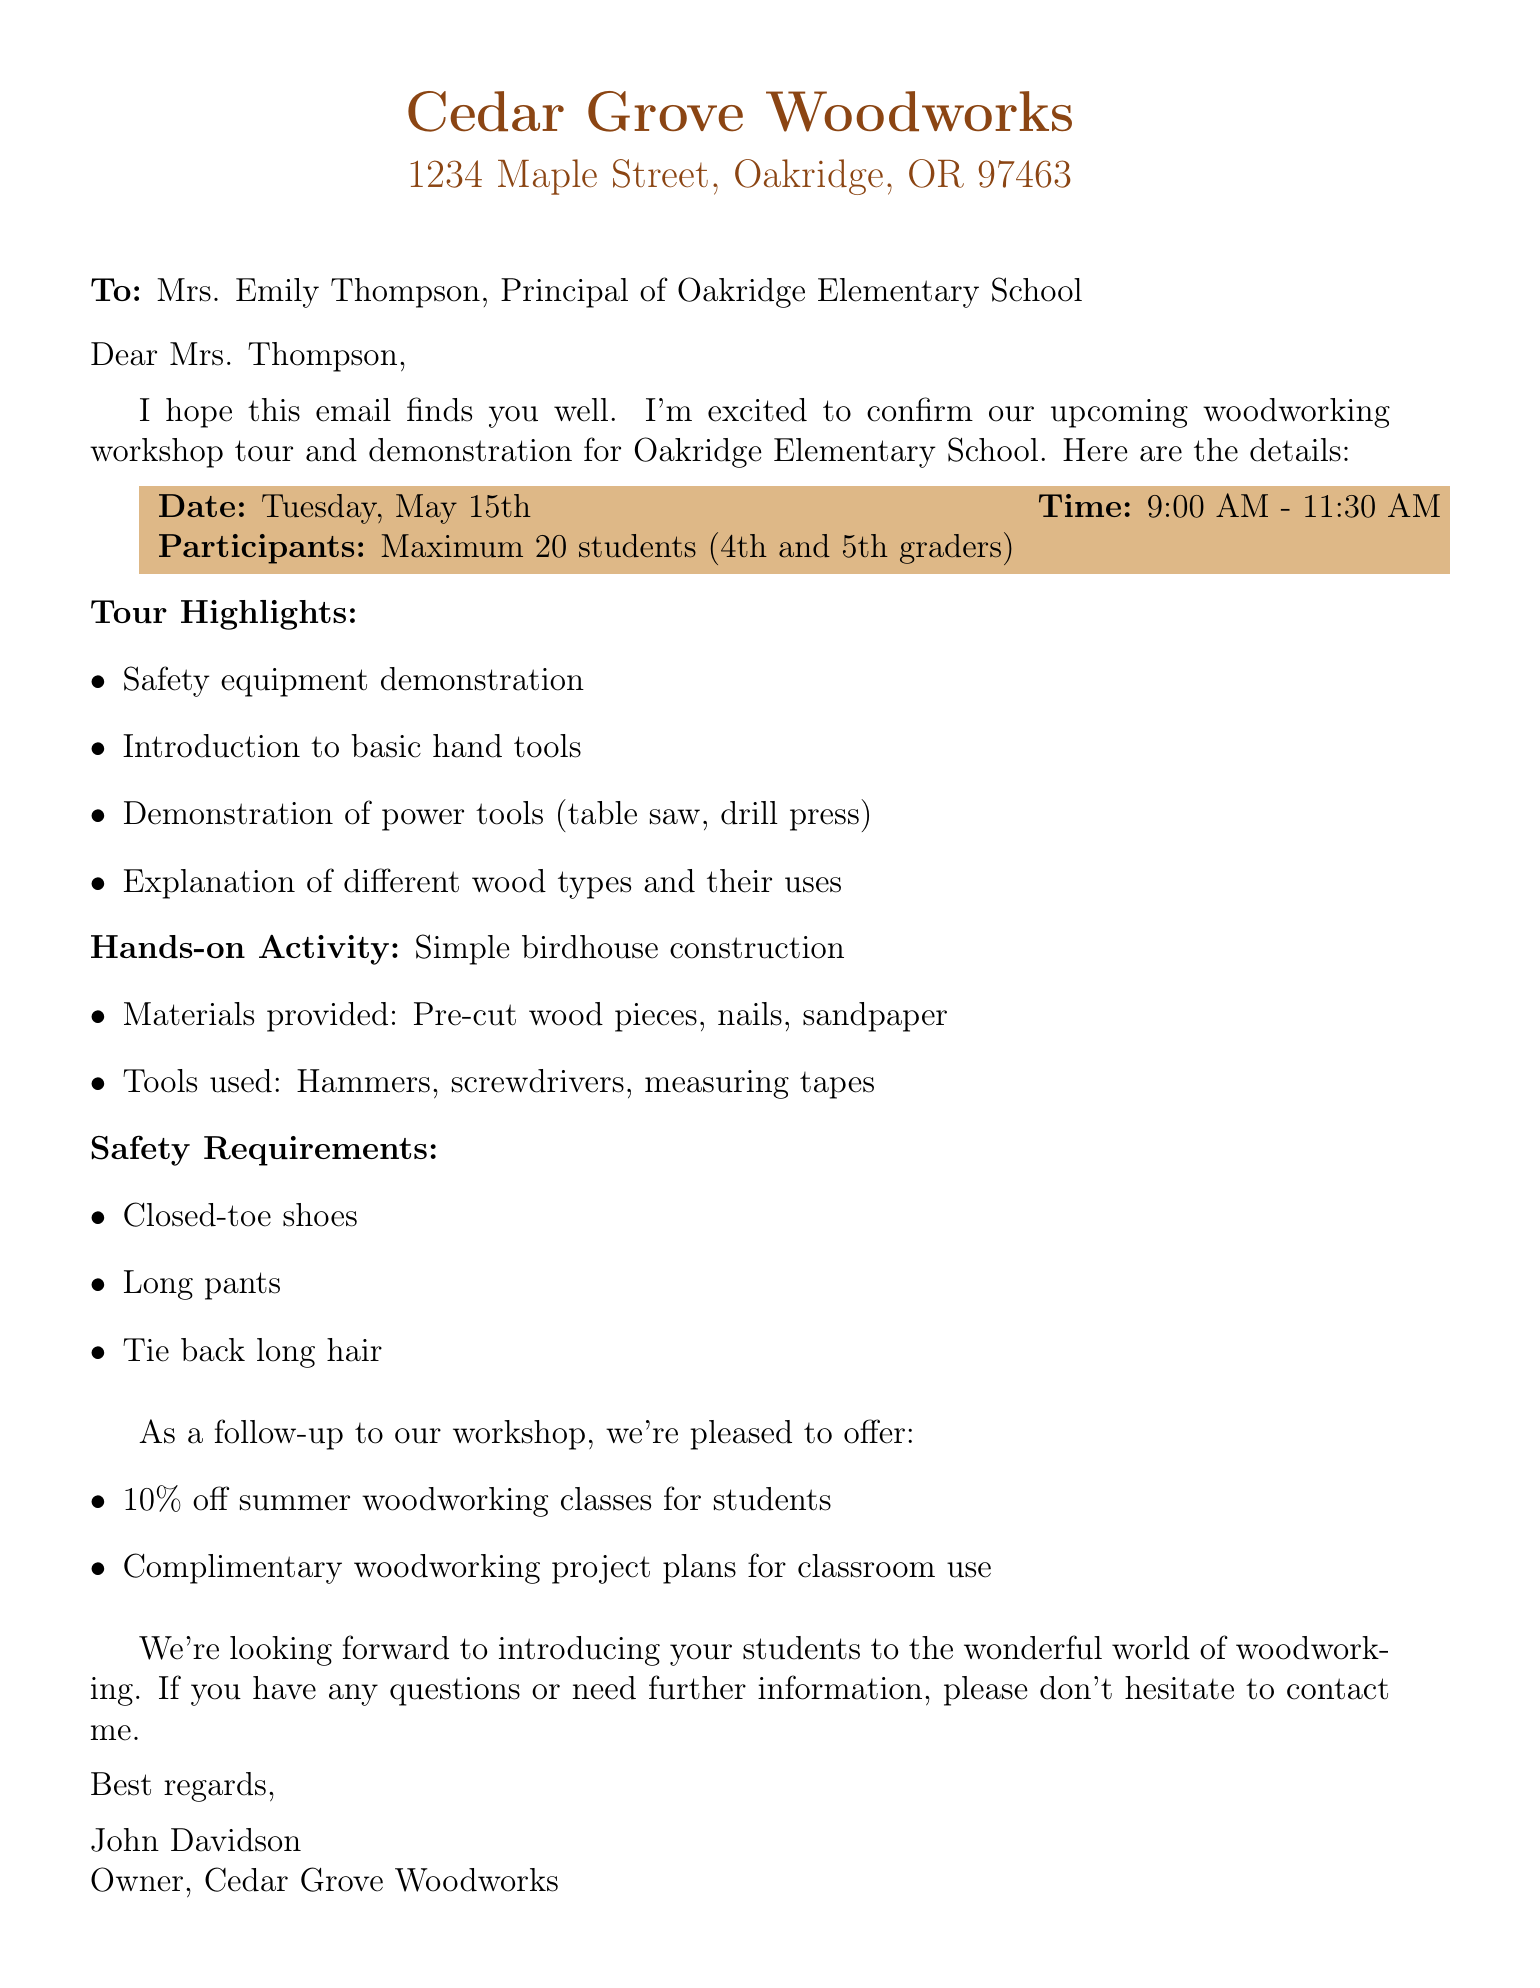What is the date of the woodworking workshop? The date is specified in the document, indicating when the workshop will take place.
Answer: Tuesday, May 15th What time does the workshop start? The workshop start time is mentioned in the schedule provided in the document.
Answer: 9:00 AM How many students can participate in the workshop? The document states the maximum number of students allowed in the workshop, which is an important detail for planning.
Answer: 20 What is the hands-on activity during the workshop? The document lists the hands-on activity that the students will engage in during the workshop.
Answer: Simple birdhouse construction What materials will be provided for the activity? The document outlines the materials that will be supplied for the hands-on project, which is essential for understanding what participants will use.
Answer: Pre-cut wood pieces, nails, sandpaper What are the safety requirements mentioned? The safety requirements are listed in the document, ensuring that participants are informed of what is needed for safety during the workshop.
Answer: Closed-toe shoes, long pants, tie back long hair Who is the owner of Cedar Grove Woodworks? The document includes the name of the woodshop owner, which is a key detail about the organization facilitating the workshop.
Answer: John Davidson What discount is offered for summer woodworking classes? The document specifies the type of offer available for students following the workshop, which helps in understanding the benefits.
Answer: 10% off What type of resources are offered to teachers? The document mentions the resources provided to teachers, which indicates support for educators beyond the workshop itself.
Answer: Complimentary woodworking project plans 